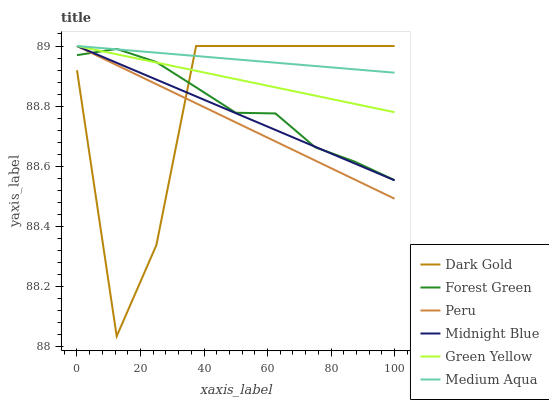Does Peru have the minimum area under the curve?
Answer yes or no. Yes. Does Medium Aqua have the maximum area under the curve?
Answer yes or no. Yes. Does Dark Gold have the minimum area under the curve?
Answer yes or no. No. Does Dark Gold have the maximum area under the curve?
Answer yes or no. No. Is Green Yellow the smoothest?
Answer yes or no. Yes. Is Dark Gold the roughest?
Answer yes or no. Yes. Is Forest Green the smoothest?
Answer yes or no. No. Is Forest Green the roughest?
Answer yes or no. No. Does Dark Gold have the lowest value?
Answer yes or no. Yes. Does Forest Green have the lowest value?
Answer yes or no. No. Does Green Yellow have the highest value?
Answer yes or no. Yes. Does Forest Green have the highest value?
Answer yes or no. No. Does Peru intersect Dark Gold?
Answer yes or no. Yes. Is Peru less than Dark Gold?
Answer yes or no. No. Is Peru greater than Dark Gold?
Answer yes or no. No. 